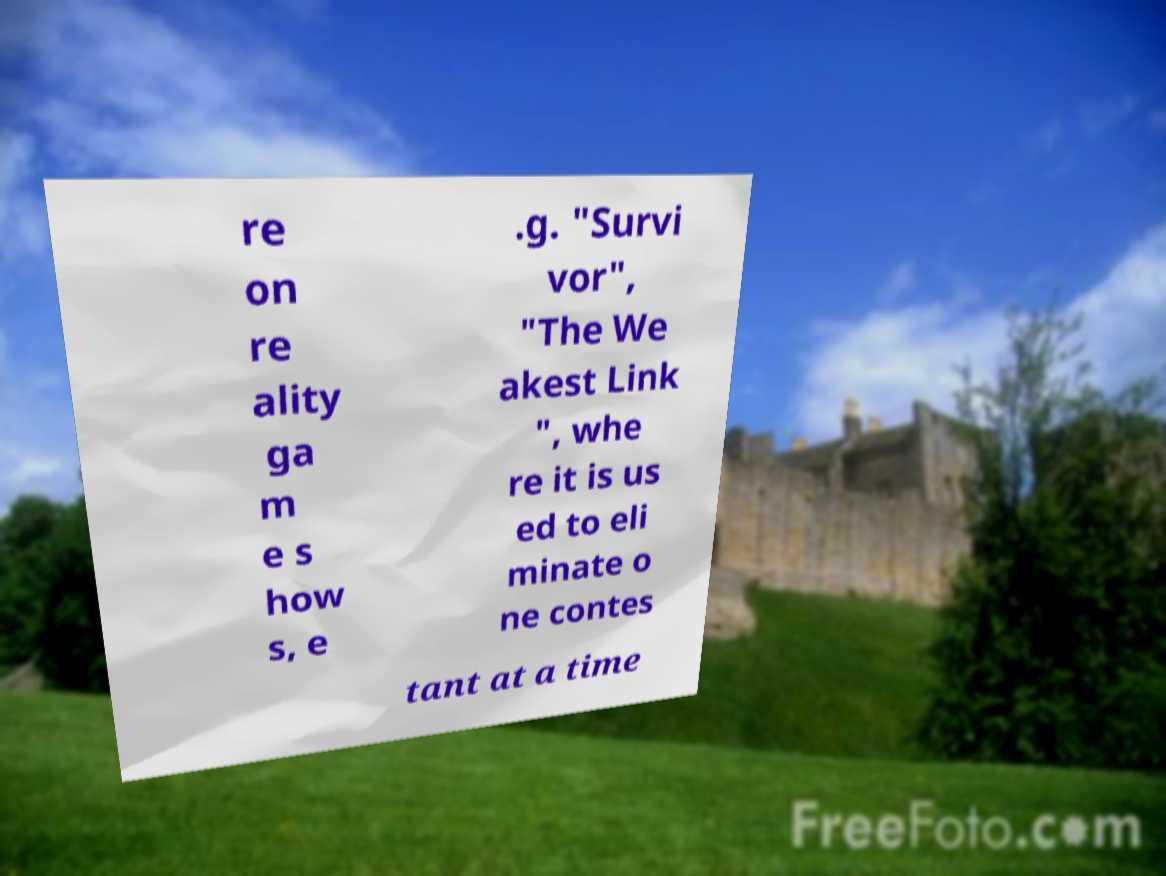I need the written content from this picture converted into text. Can you do that? re on re ality ga m e s how s, e .g. "Survi vor", "The We akest Link ", whe re it is us ed to eli minate o ne contes tant at a time 